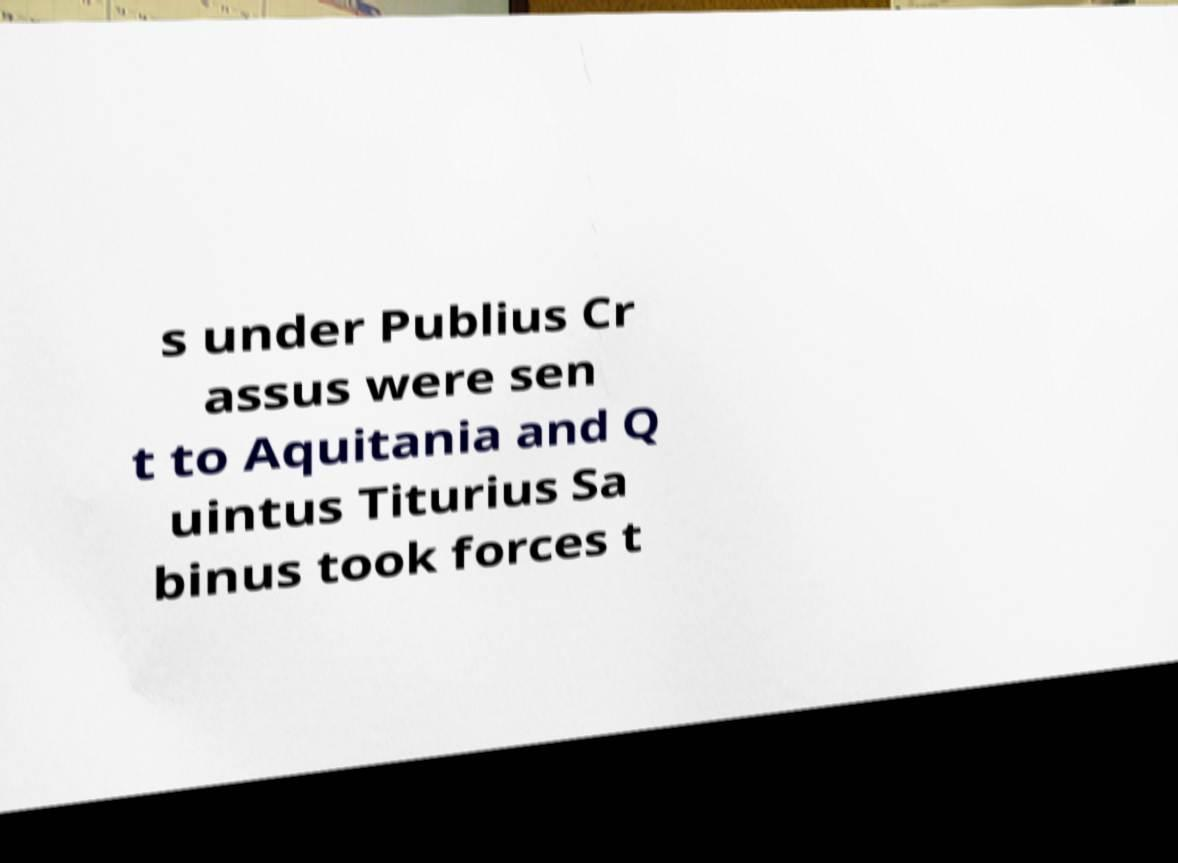Please identify and transcribe the text found in this image. s under Publius Cr assus were sen t to Aquitania and Q uintus Titurius Sa binus took forces t 